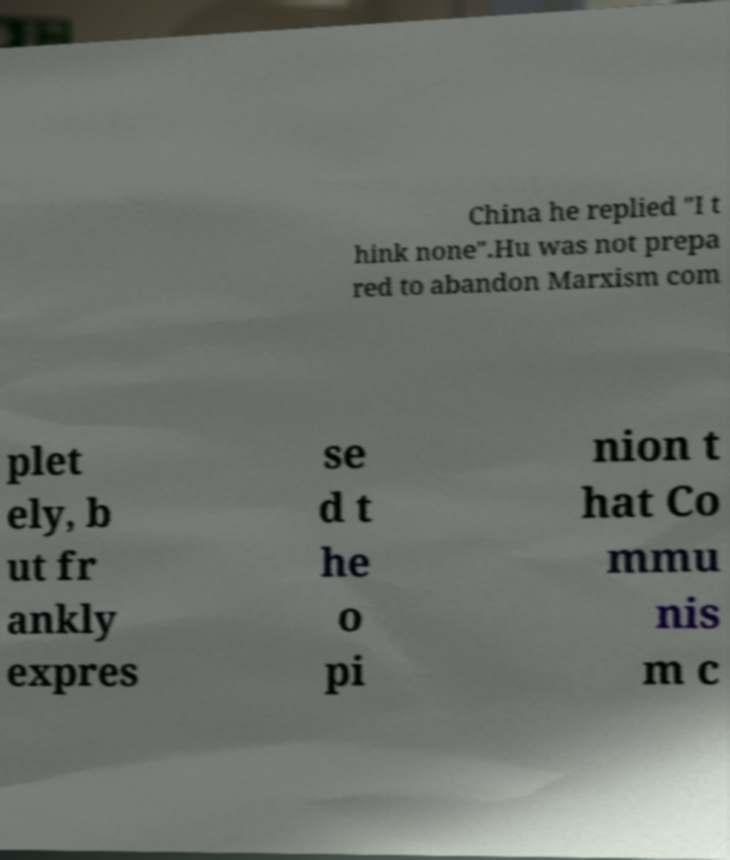What messages or text are displayed in this image? I need them in a readable, typed format. China he replied "I t hink none".Hu was not prepa red to abandon Marxism com plet ely, b ut fr ankly expres se d t he o pi nion t hat Co mmu nis m c 